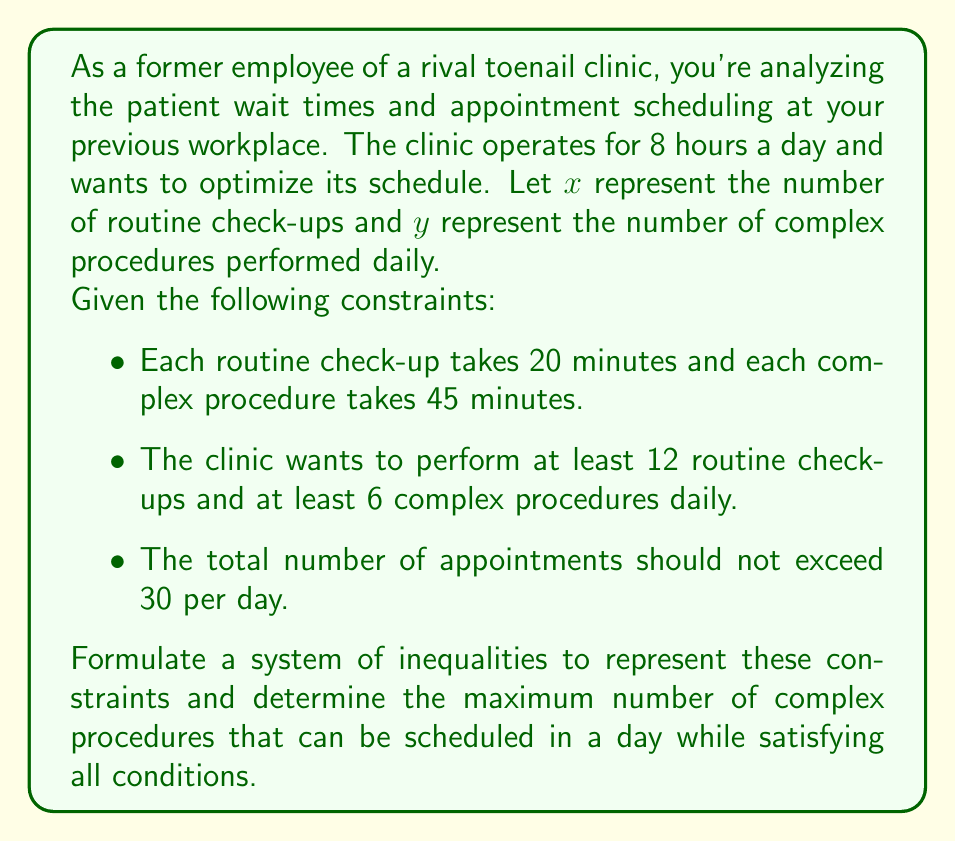Can you solve this math problem? Let's approach this step-by-step:

1) First, let's formulate the system of inequalities:

   a) Time constraint: 
      $20x + 45y \leq 480$ (8 hours = 480 minutes)

   b) Minimum appointments:
      $x \geq 12$ (at least 12 routine check-ups)
      $y \geq 6$ (at least 6 complex procedures)

   c) Maximum total appointments:
      $x + y \leq 30$

2) Now we have the system:
   $$\begin{cases}
   20x + 45y \leq 480 \\
   x \geq 12 \\
   y \geq 6 \\
   x + y \leq 30
   \end{cases}$$

3) To maximize $y$, we need to find the intersection of these inequalities.

4) From $x \geq 12$ and $x + y \leq 30$, we can deduce:
   $12 + y \leq 30$
   $y \leq 18$

5) Substituting $x = 12$ (minimum) into the time constraint:
   $20(12) + 45y \leq 480$
   $240 + 45y \leq 480$
   $45y \leq 240$
   $y \leq 5.33$

6) However, we need at least 6 complex procedures, so this boundary doesn't apply.

7) The limiting factor is the time constraint. Substituting $x = 12$:
   $20(12) + 45y = 480$
   $240 + 45y = 480$
   $45y = 240$
   $y = 5.33$

8) Rounding down to the nearest integer (as we can't schedule partial procedures), the maximum number of complex procedures is 5.

9) However, this doesn't meet the minimum requirement of 6 complex procedures.

10) Therefore, the maximum number of complex procedures possible while meeting all constraints is 6.
Answer: The maximum number of complex procedures that can be scheduled in a day while satisfying all conditions is 6. 